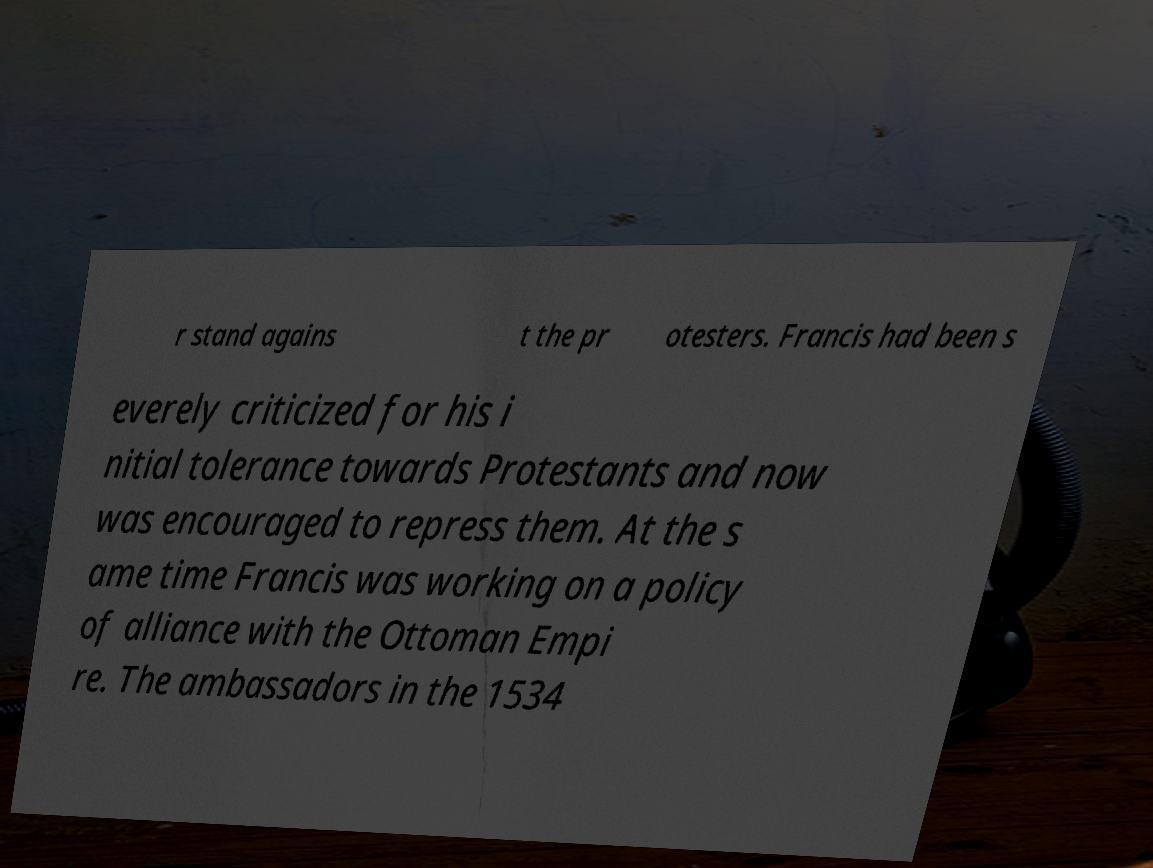What messages or text are displayed in this image? I need them in a readable, typed format. r stand agains t the pr otesters. Francis had been s everely criticized for his i nitial tolerance towards Protestants and now was encouraged to repress them. At the s ame time Francis was working on a policy of alliance with the Ottoman Empi re. The ambassadors in the 1534 